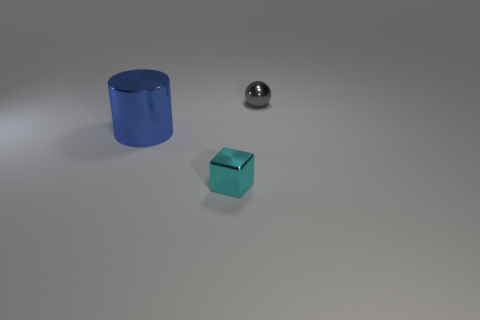Subtract all yellow cylinders. Subtract all green cubes. How many cylinders are left? 1 Add 2 large metallic cylinders. How many objects exist? 5 Subtract all cylinders. How many objects are left? 2 Subtract all big blue rubber balls. Subtract all cyan shiny things. How many objects are left? 2 Add 2 gray metal spheres. How many gray metal spheres are left? 3 Add 1 gray shiny spheres. How many gray shiny spheres exist? 2 Subtract 0 purple cylinders. How many objects are left? 3 